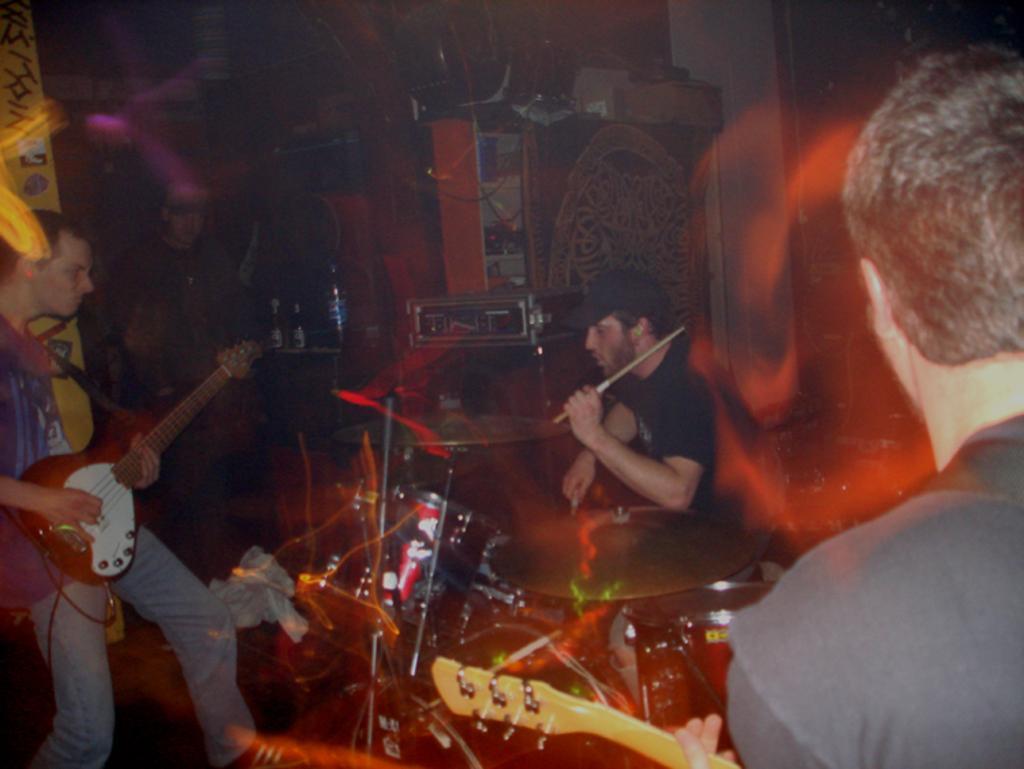In one or two sentences, can you explain what this image depicts? This picture is clicked in musical concert. On the left bottom of the picture, we see man in blue t-shirt is holding guitar in his hands and playing it. In the middle of the picture, man in black t-shirt is playing drums. Behind them, we see a cupboard and a table on which water bottle is placed. 